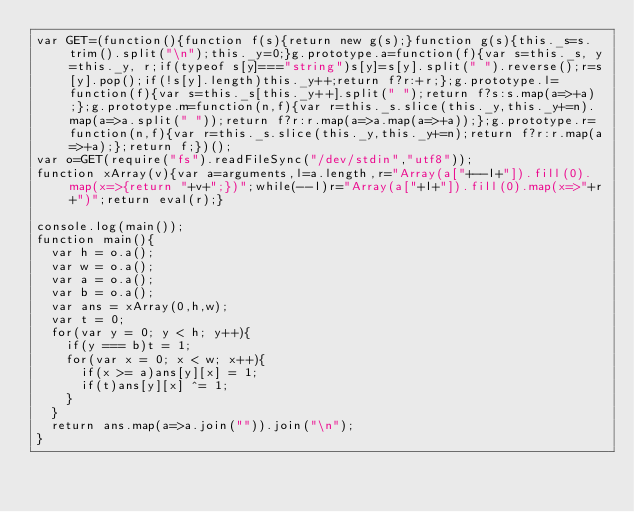Convert code to text. <code><loc_0><loc_0><loc_500><loc_500><_JavaScript_>var GET=(function(){function f(s){return new g(s);}function g(s){this._s=s.trim().split("\n");this._y=0;}g.prototype.a=function(f){var s=this._s, y=this._y, r;if(typeof s[y]==="string")s[y]=s[y].split(" ").reverse();r=s[y].pop();if(!s[y].length)this._y++;return f?r:+r;};g.prototype.l=function(f){var s=this._s[this._y++].split(" ");return f?s:s.map(a=>+a);};g.prototype.m=function(n,f){var r=this._s.slice(this._y,this._y+=n).map(a=>a.split(" "));return f?r:r.map(a=>a.map(a=>+a));};g.prototype.r=function(n,f){var r=this._s.slice(this._y,this._y+=n);return f?r:r.map(a=>+a);};return f;})();
var o=GET(require("fs").readFileSync("/dev/stdin","utf8"));
function xArray(v){var a=arguments,l=a.length,r="Array(a["+--l+"]).fill(0).map(x=>{return "+v+";})";while(--l)r="Array(a["+l+"]).fill(0).map(x=>"+r+")";return eval(r);}

console.log(main());
function main(){
  var h = o.a();
  var w = o.a();
  var a = o.a();
  var b = o.a();
  var ans = xArray(0,h,w);
  var t = 0;
  for(var y = 0; y < h; y++){
    if(y === b)t = 1;
    for(var x = 0; x < w; x++){
      if(x >= a)ans[y][x] = 1;
      if(t)ans[y][x] ^= 1;
    }
  }
  return ans.map(a=>a.join("")).join("\n");
}</code> 